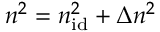Convert formula to latex. <formula><loc_0><loc_0><loc_500><loc_500>n ^ { 2 } = n _ { i d } ^ { 2 } + \Delta n ^ { 2 }</formula> 